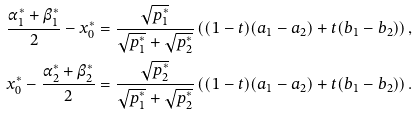<formula> <loc_0><loc_0><loc_500><loc_500>\frac { \alpha _ { 1 } ^ { * } + \beta _ { 1 } ^ { * } } { 2 } - x _ { 0 } ^ { * } & = \frac { \sqrt { p _ { 1 } ^ { * } } } { \sqrt { p _ { 1 } ^ { * } } + \sqrt { p _ { 2 } ^ { * } } } \left ( ( 1 - t ) ( a _ { 1 } - a _ { 2 } ) + t ( b _ { 1 } - b _ { 2 } ) \right ) , \\ x _ { 0 } ^ { * } - \frac { \alpha _ { 2 } ^ { * } + \beta _ { 2 } ^ { * } } { 2 } & = \frac { \sqrt { p _ { 2 } ^ { * } } } { \sqrt { p _ { 1 } ^ { * } } + \sqrt { p _ { 2 } ^ { * } } } \left ( ( 1 - t ) ( a _ { 1 } - a _ { 2 } ) + t ( b _ { 1 } - b _ { 2 } ) \right ) .</formula> 